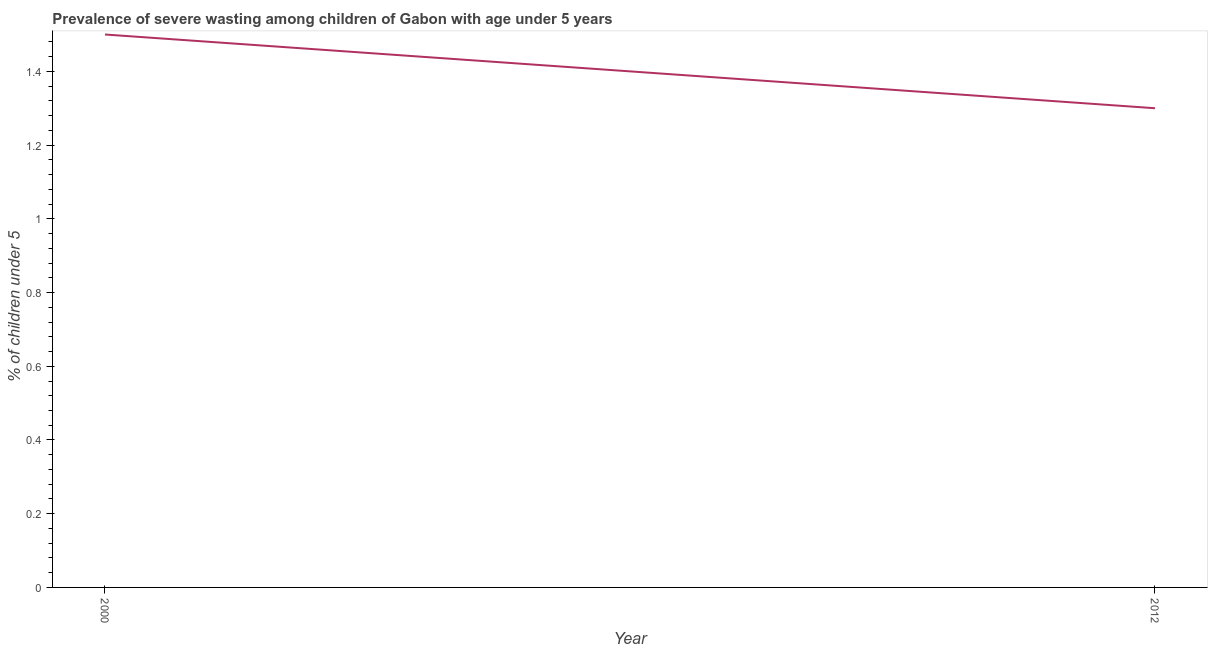Across all years, what is the maximum prevalence of severe wasting?
Your answer should be very brief. 1.5. Across all years, what is the minimum prevalence of severe wasting?
Give a very brief answer. 1.3. In which year was the prevalence of severe wasting maximum?
Provide a succinct answer. 2000. What is the sum of the prevalence of severe wasting?
Offer a terse response. 2.8. What is the difference between the prevalence of severe wasting in 2000 and 2012?
Provide a succinct answer. 0.2. What is the average prevalence of severe wasting per year?
Give a very brief answer. 1.4. What is the median prevalence of severe wasting?
Your answer should be very brief. 1.4. What is the ratio of the prevalence of severe wasting in 2000 to that in 2012?
Offer a terse response. 1.15. Is the prevalence of severe wasting in 2000 less than that in 2012?
Your response must be concise. No. Are the values on the major ticks of Y-axis written in scientific E-notation?
Offer a very short reply. No. Does the graph contain grids?
Provide a succinct answer. No. What is the title of the graph?
Provide a succinct answer. Prevalence of severe wasting among children of Gabon with age under 5 years. What is the label or title of the Y-axis?
Your answer should be compact.  % of children under 5. What is the  % of children under 5 in 2012?
Your answer should be very brief. 1.3. What is the difference between the  % of children under 5 in 2000 and 2012?
Your answer should be very brief. 0.2. What is the ratio of the  % of children under 5 in 2000 to that in 2012?
Provide a short and direct response. 1.15. 